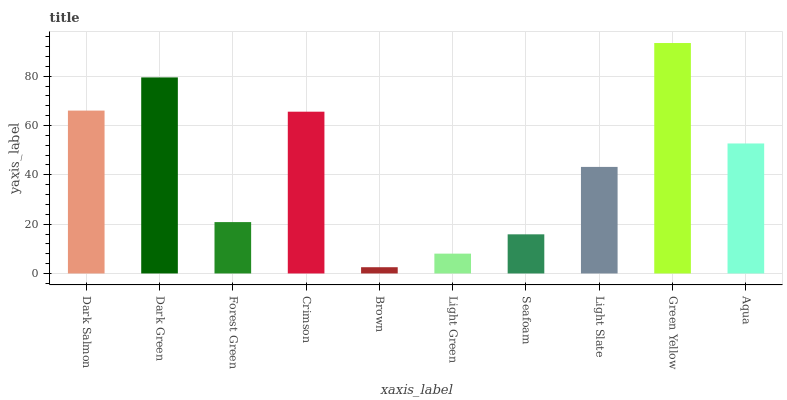Is Brown the minimum?
Answer yes or no. Yes. Is Green Yellow the maximum?
Answer yes or no. Yes. Is Dark Green the minimum?
Answer yes or no. No. Is Dark Green the maximum?
Answer yes or no. No. Is Dark Green greater than Dark Salmon?
Answer yes or no. Yes. Is Dark Salmon less than Dark Green?
Answer yes or no. Yes. Is Dark Salmon greater than Dark Green?
Answer yes or no. No. Is Dark Green less than Dark Salmon?
Answer yes or no. No. Is Aqua the high median?
Answer yes or no. Yes. Is Light Slate the low median?
Answer yes or no. Yes. Is Seafoam the high median?
Answer yes or no. No. Is Dark Salmon the low median?
Answer yes or no. No. 